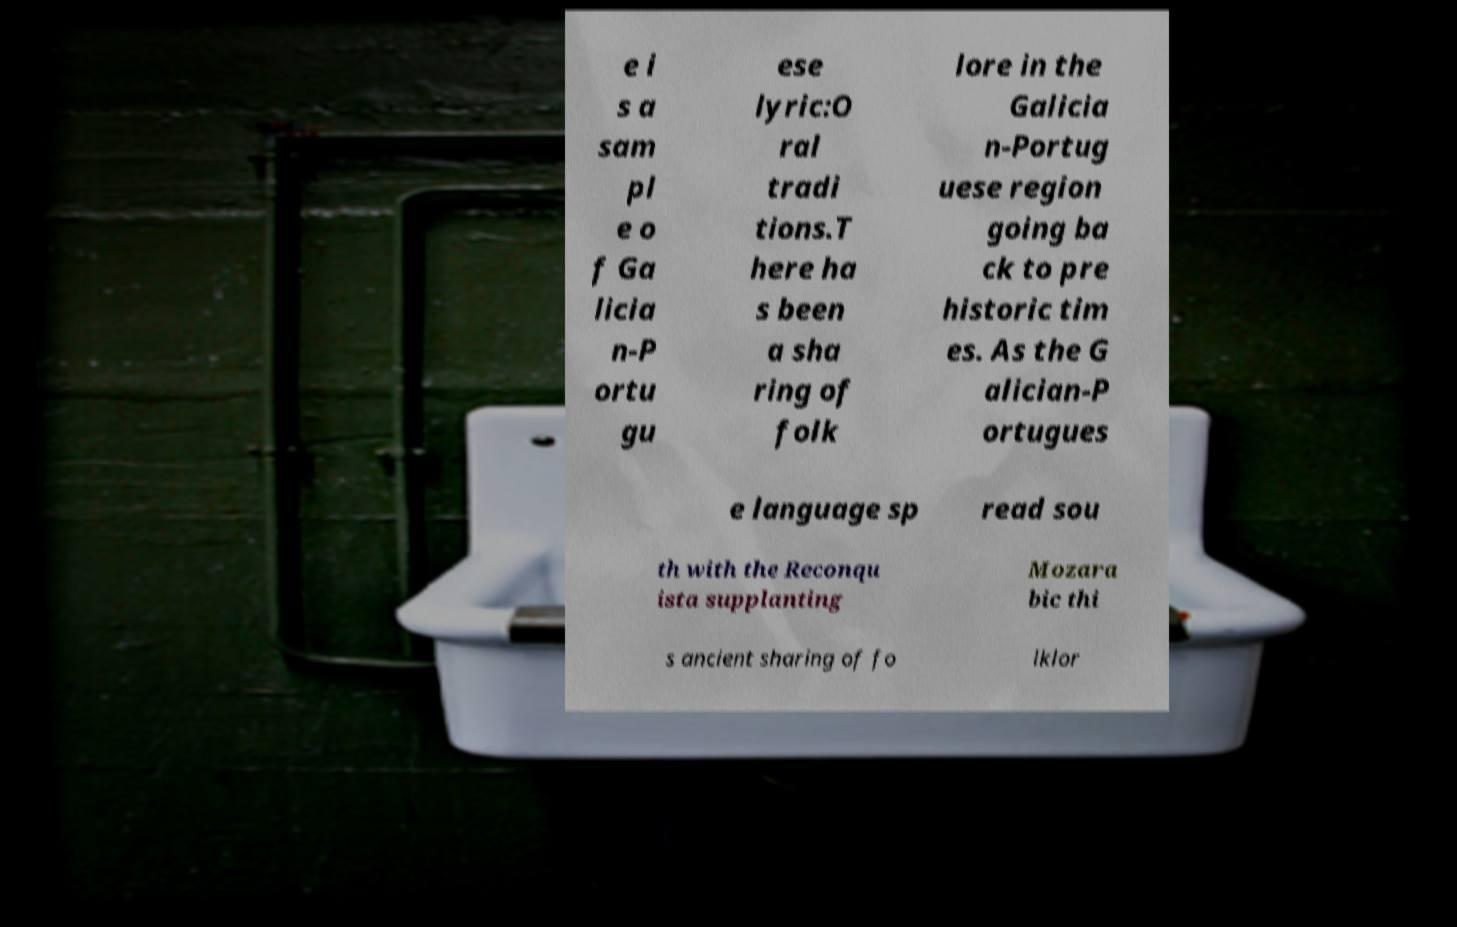Please read and relay the text visible in this image. What does it say? e i s a sam pl e o f Ga licia n-P ortu gu ese lyric:O ral tradi tions.T here ha s been a sha ring of folk lore in the Galicia n-Portug uese region going ba ck to pre historic tim es. As the G alician-P ortugues e language sp read sou th with the Reconqu ista supplanting Mozara bic thi s ancient sharing of fo lklor 